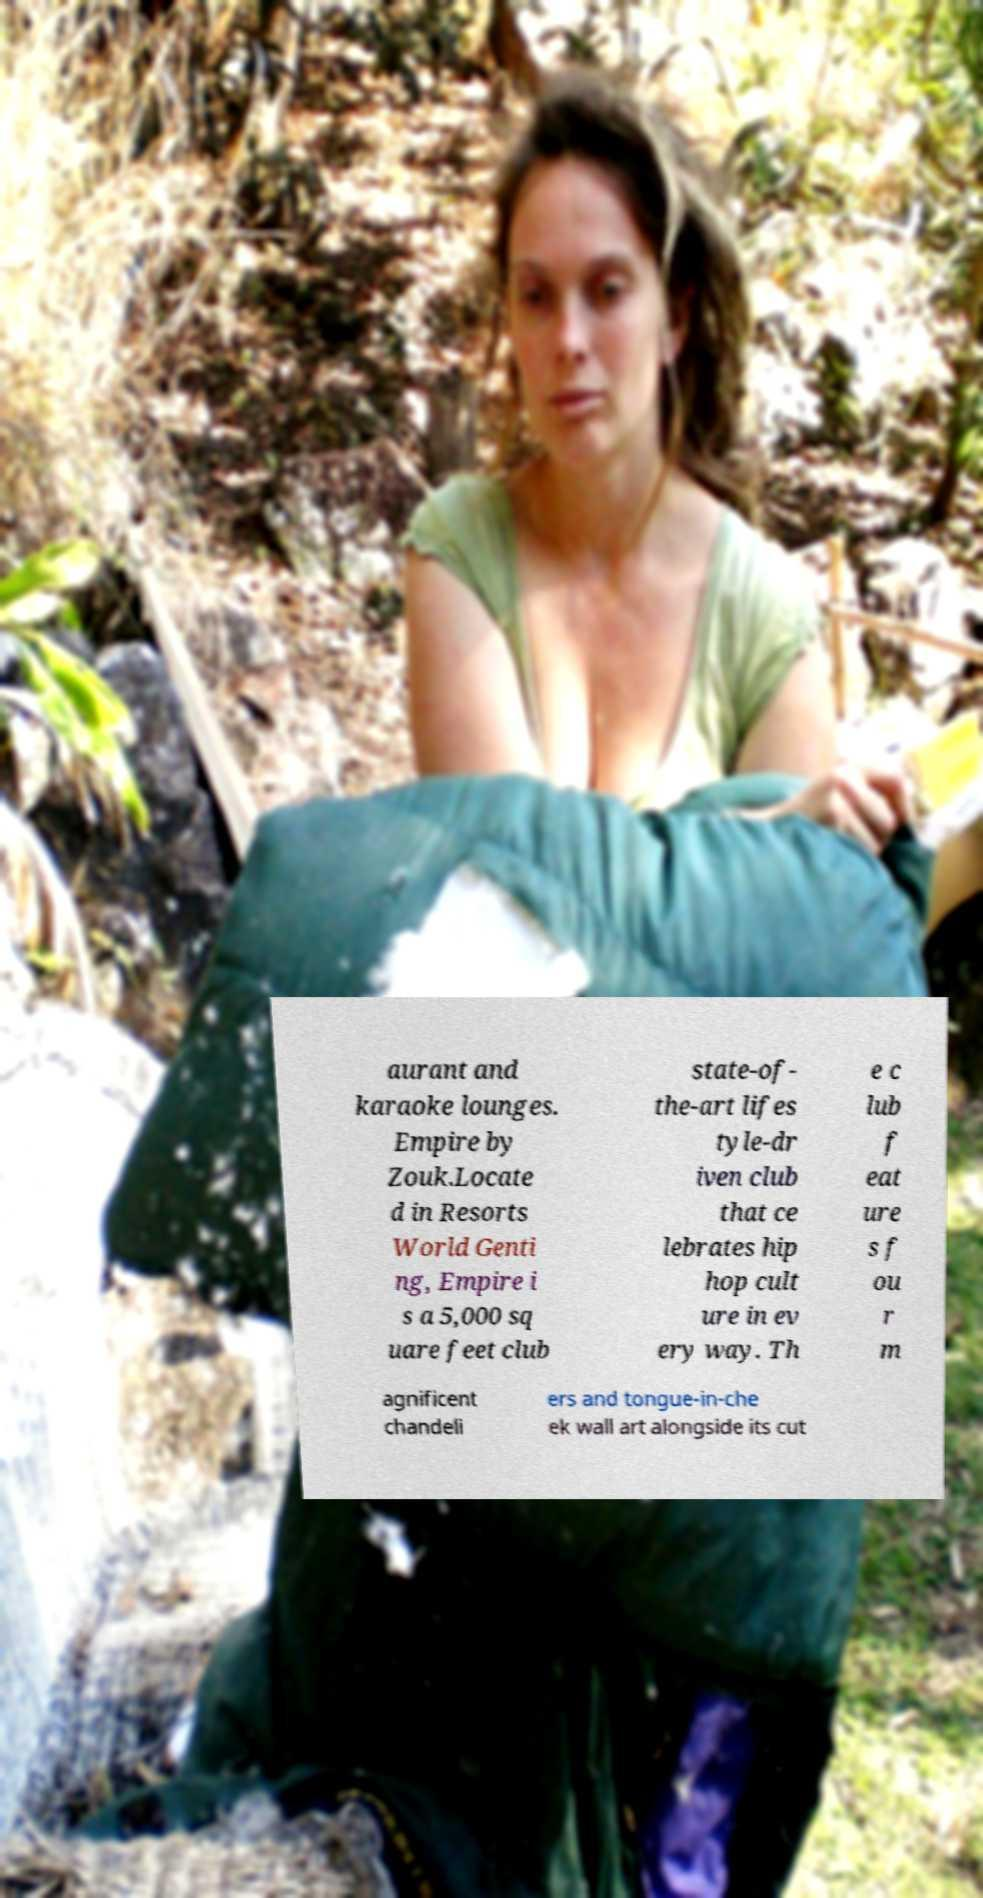There's text embedded in this image that I need extracted. Can you transcribe it verbatim? aurant and karaoke lounges. Empire by Zouk.Locate d in Resorts World Genti ng, Empire i s a 5,000 sq uare feet club state-of- the-art lifes tyle-dr iven club that ce lebrates hip hop cult ure in ev ery way. Th e c lub f eat ure s f ou r m agnificent chandeli ers and tongue-in-che ek wall art alongside its cut 